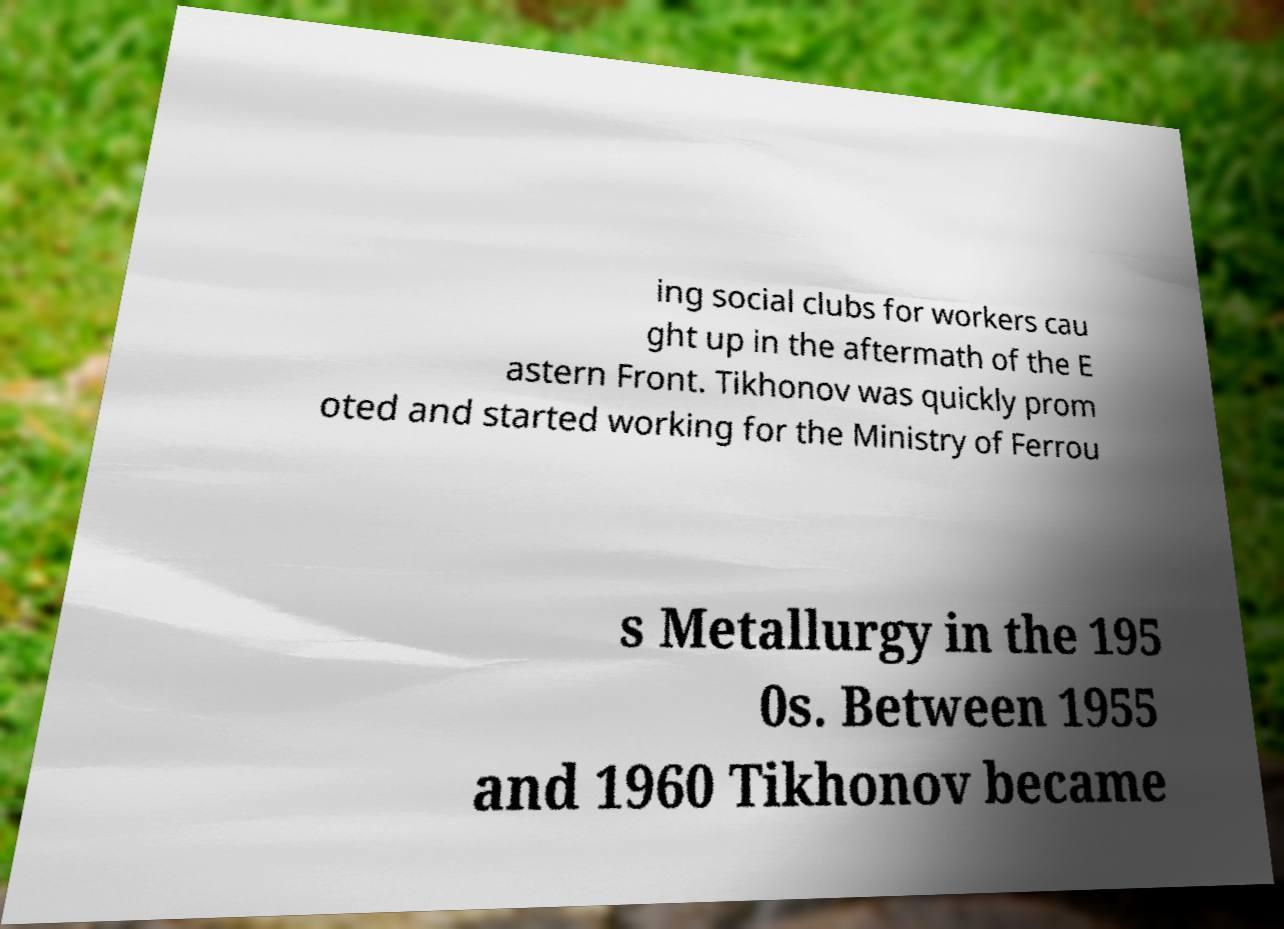Can you accurately transcribe the text from the provided image for me? ing social clubs for workers cau ght up in the aftermath of the E astern Front. Tikhonov was quickly prom oted and started working for the Ministry of Ferrou s Metallurgy in the 195 0s. Between 1955 and 1960 Tikhonov became 